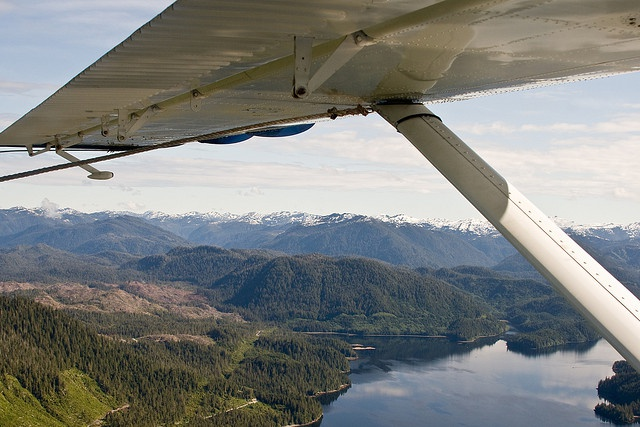Describe the objects in this image and their specific colors. I can see a airplane in darkgray, gray, and lightgray tones in this image. 